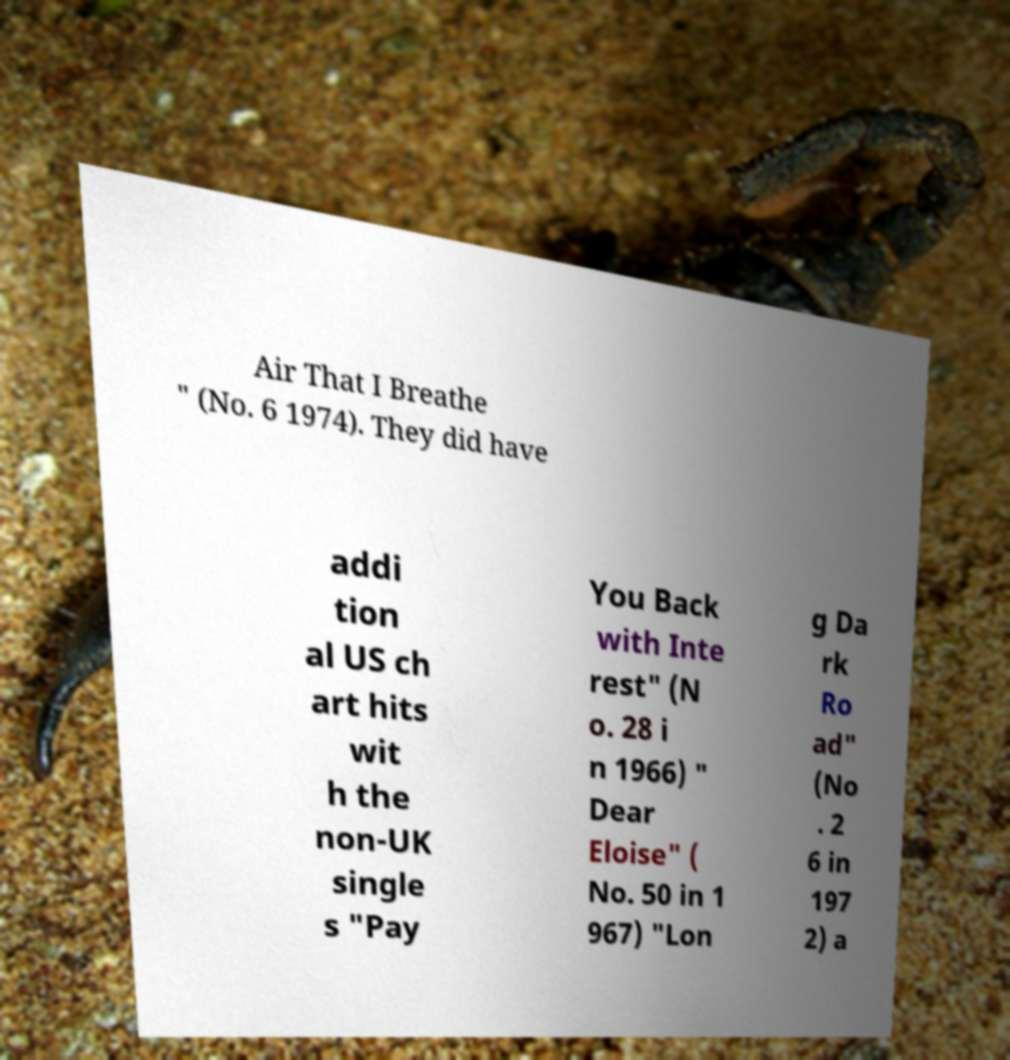Could you extract and type out the text from this image? Air That I Breathe " (No. 6 1974). They did have addi tion al US ch art hits wit h the non-UK single s "Pay You Back with Inte rest" (N o. 28 i n 1966) " Dear Eloise" ( No. 50 in 1 967) "Lon g Da rk Ro ad" (No . 2 6 in 197 2) a 